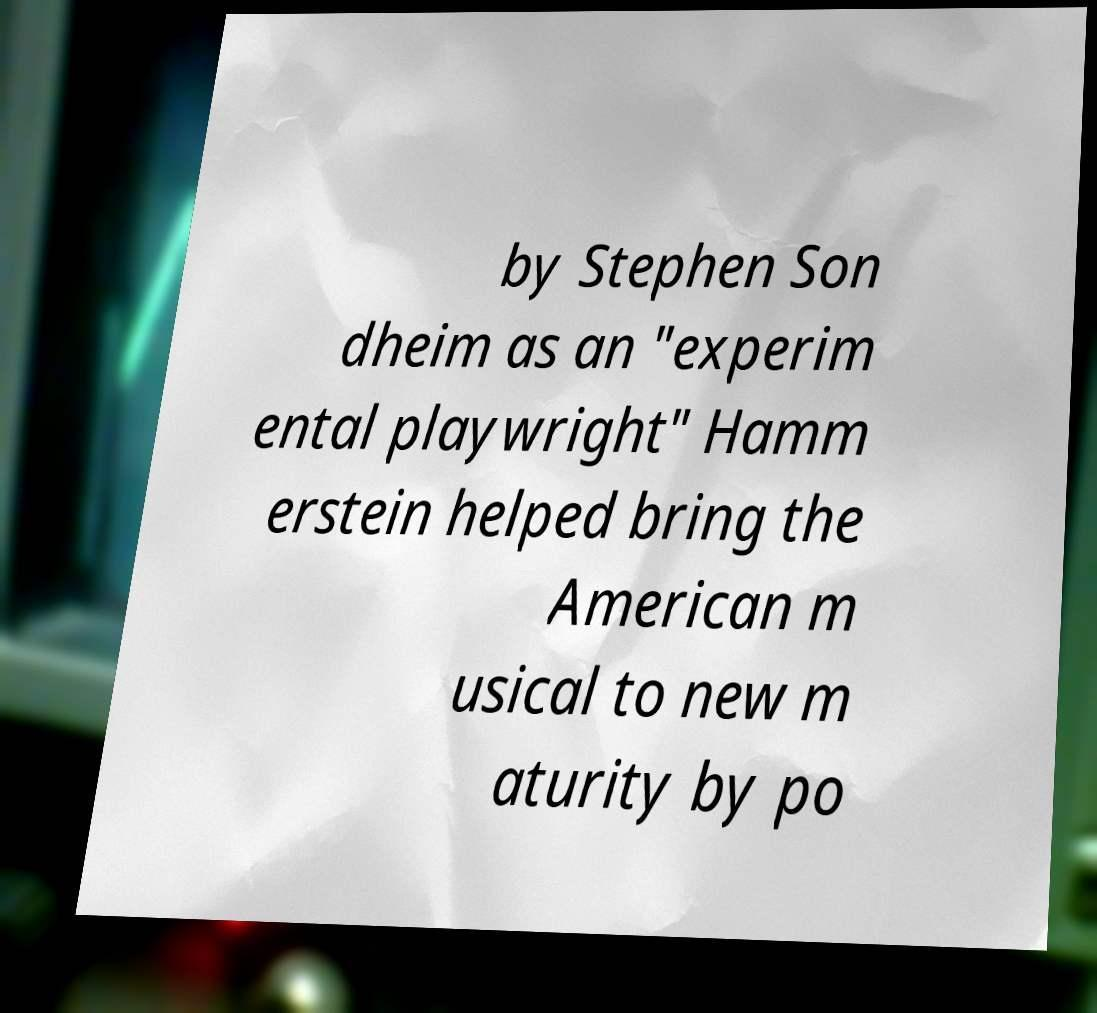Please identify and transcribe the text found in this image. by Stephen Son dheim as an "experim ental playwright" Hamm erstein helped bring the American m usical to new m aturity by po 